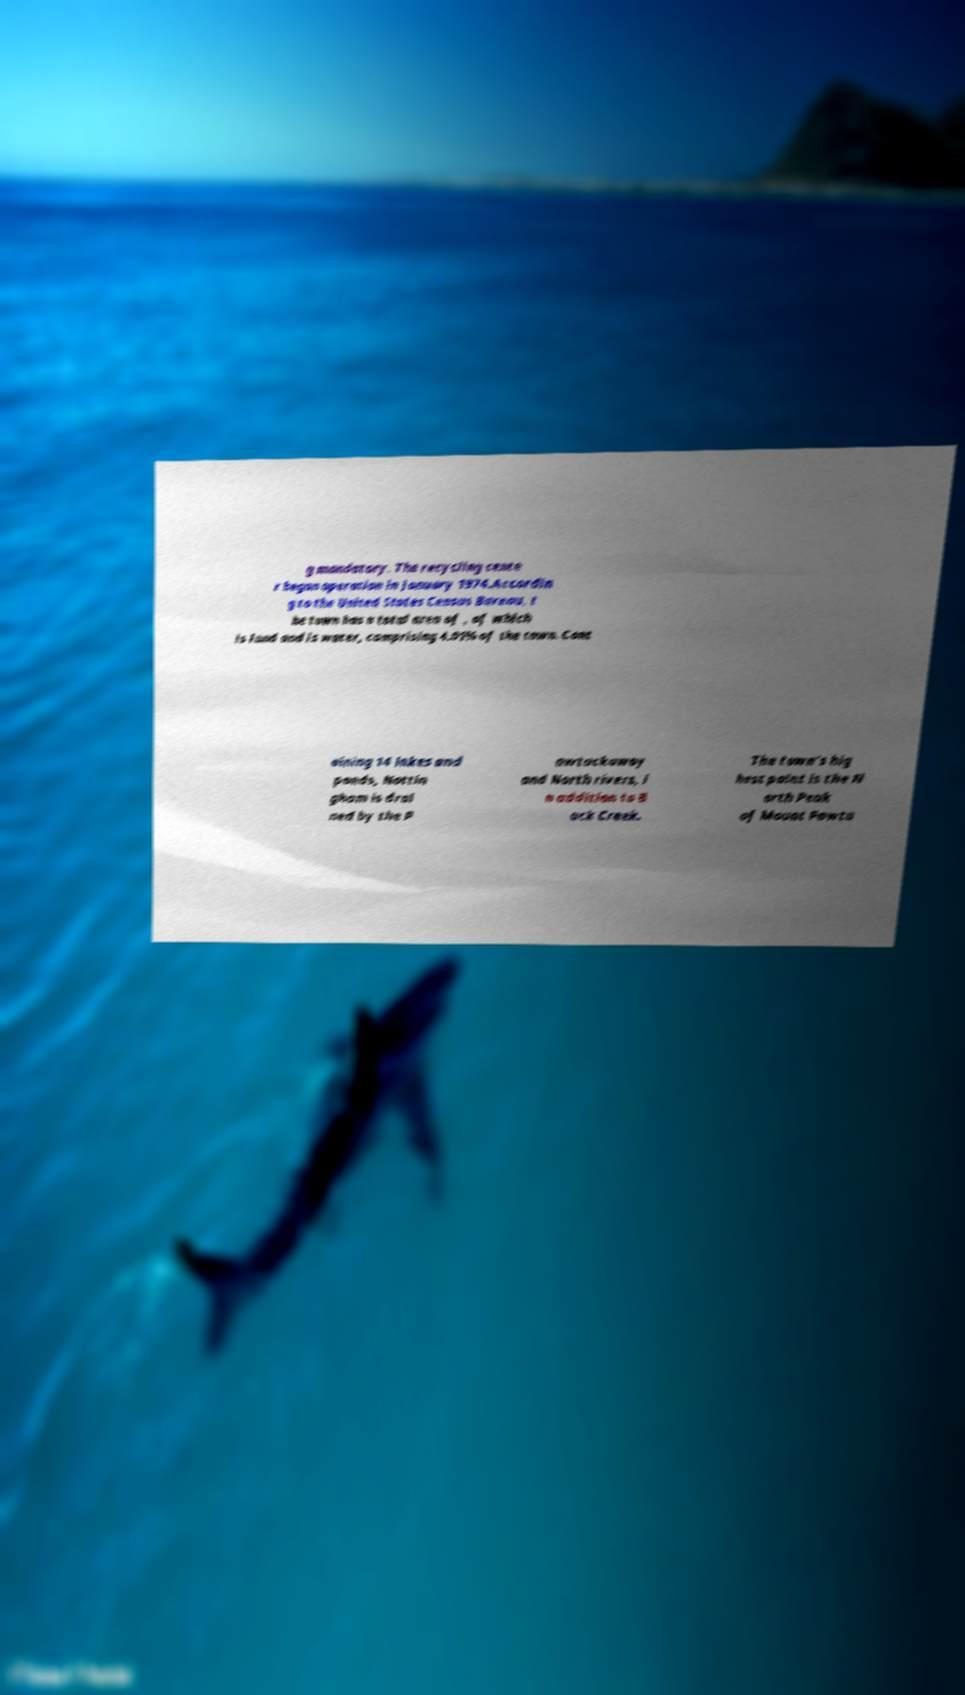Could you assist in decoding the text presented in this image and type it out clearly? g mandatory. The recycling cente r began operation in January 1974.Accordin g to the United States Census Bureau, t he town has a total area of , of which is land and is water, comprising 4.01% of the town. Cont aining 14 lakes and ponds, Nottin gham is drai ned by the P awtuckaway and North rivers, i n addition to B ack Creek. The town's hig hest point is the N orth Peak of Mount Pawtu 